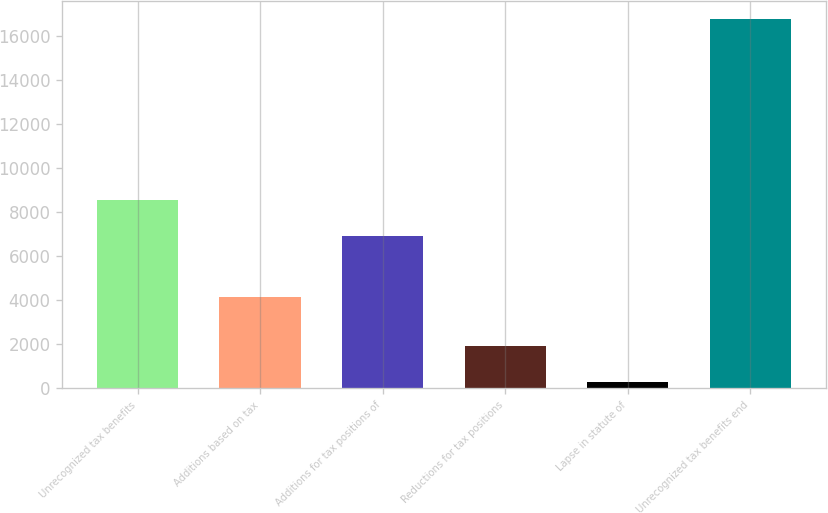Convert chart to OTSL. <chart><loc_0><loc_0><loc_500><loc_500><bar_chart><fcel>Unrecognized tax benefits<fcel>Additions based on tax<fcel>Additions for tax positions of<fcel>Reductions for tax positions<fcel>Lapse in statute of<fcel>Unrecognized tax benefits end<nl><fcel>8561.2<fcel>4172<fcel>6911<fcel>1936.2<fcel>286<fcel>16788<nl></chart> 